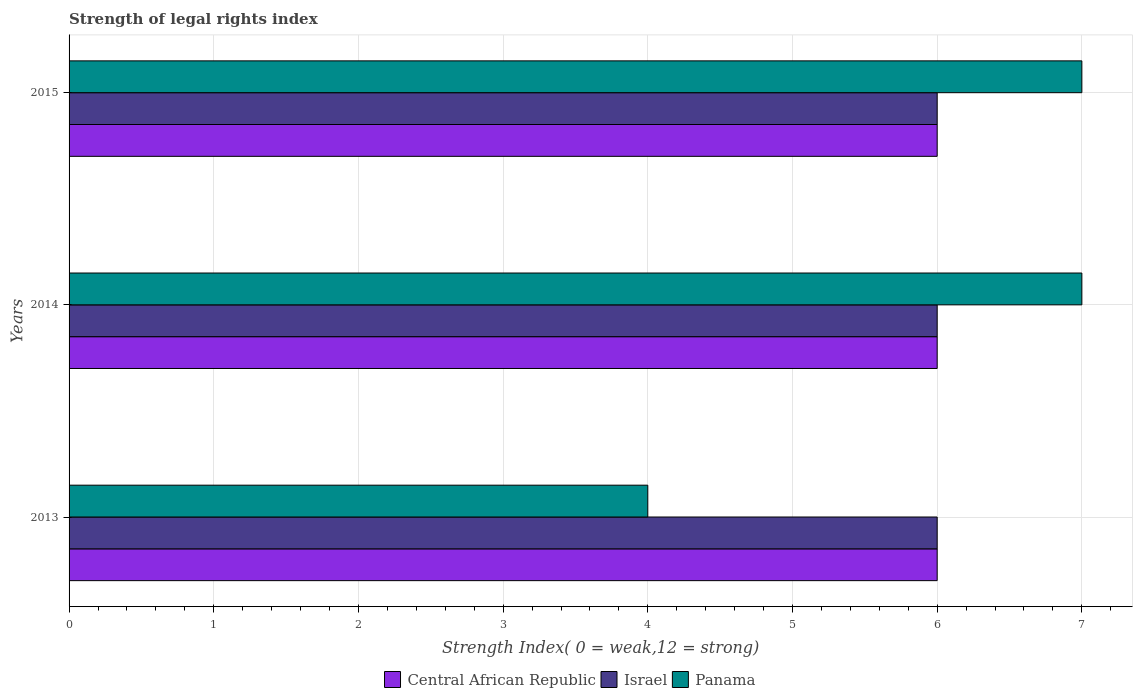Are the number of bars per tick equal to the number of legend labels?
Provide a succinct answer. Yes. Are the number of bars on each tick of the Y-axis equal?
Make the answer very short. Yes. How many bars are there on the 2nd tick from the bottom?
Your answer should be compact. 3. What is the strength index in Panama in 2013?
Ensure brevity in your answer.  4. Across all years, what is the maximum strength index in Panama?
Make the answer very short. 7. Across all years, what is the minimum strength index in Panama?
Give a very brief answer. 4. In which year was the strength index in Panama minimum?
Your answer should be compact. 2013. What is the total strength index in Israel in the graph?
Ensure brevity in your answer.  18. What is the difference between the strength index in Panama in 2014 and that in 2015?
Provide a short and direct response. 0. What is the difference between the strength index in Central African Republic in 2013 and the strength index in Panama in 2015?
Your answer should be compact. -1. What is the average strength index in Israel per year?
Your response must be concise. 6. What is the difference between the highest and the second highest strength index in Israel?
Offer a terse response. 0. What is the difference between the highest and the lowest strength index in Panama?
Offer a very short reply. 3. In how many years, is the strength index in Israel greater than the average strength index in Israel taken over all years?
Offer a very short reply. 0. What does the 1st bar from the top in 2015 represents?
Give a very brief answer. Panama. Is it the case that in every year, the sum of the strength index in Israel and strength index in Central African Republic is greater than the strength index in Panama?
Keep it short and to the point. Yes. Are all the bars in the graph horizontal?
Provide a succinct answer. Yes. What is the difference between two consecutive major ticks on the X-axis?
Offer a very short reply. 1. Does the graph contain grids?
Provide a succinct answer. Yes. Where does the legend appear in the graph?
Keep it short and to the point. Bottom center. How many legend labels are there?
Your answer should be compact. 3. How are the legend labels stacked?
Make the answer very short. Horizontal. What is the title of the graph?
Make the answer very short. Strength of legal rights index. Does "Uzbekistan" appear as one of the legend labels in the graph?
Provide a succinct answer. No. What is the label or title of the X-axis?
Provide a short and direct response. Strength Index( 0 = weak,12 = strong). What is the label or title of the Y-axis?
Give a very brief answer. Years. What is the Strength Index( 0 = weak,12 = strong) in Israel in 2013?
Ensure brevity in your answer.  6. What is the Strength Index( 0 = weak,12 = strong) of Panama in 2013?
Your response must be concise. 4. What is the Strength Index( 0 = weak,12 = strong) in Central African Republic in 2015?
Your answer should be compact. 6. What is the Strength Index( 0 = weak,12 = strong) in Panama in 2015?
Your answer should be compact. 7. Across all years, what is the maximum Strength Index( 0 = weak,12 = strong) of Central African Republic?
Make the answer very short. 6. Across all years, what is the maximum Strength Index( 0 = weak,12 = strong) in Israel?
Keep it short and to the point. 6. Across all years, what is the maximum Strength Index( 0 = weak,12 = strong) of Panama?
Keep it short and to the point. 7. Across all years, what is the minimum Strength Index( 0 = weak,12 = strong) in Panama?
Your answer should be compact. 4. What is the total Strength Index( 0 = weak,12 = strong) in Panama in the graph?
Ensure brevity in your answer.  18. What is the difference between the Strength Index( 0 = weak,12 = strong) of Central African Republic in 2013 and that in 2014?
Make the answer very short. 0. What is the difference between the Strength Index( 0 = weak,12 = strong) in Israel in 2013 and that in 2014?
Your answer should be compact. 0. What is the difference between the Strength Index( 0 = weak,12 = strong) of Panama in 2013 and that in 2014?
Your response must be concise. -3. What is the difference between the Strength Index( 0 = weak,12 = strong) of Central African Republic in 2013 and that in 2015?
Your answer should be compact. 0. What is the difference between the Strength Index( 0 = weak,12 = strong) in Panama in 2013 and that in 2015?
Your answer should be compact. -3. What is the difference between the Strength Index( 0 = weak,12 = strong) in Israel in 2014 and that in 2015?
Your answer should be very brief. 0. What is the difference between the Strength Index( 0 = weak,12 = strong) of Panama in 2014 and that in 2015?
Offer a terse response. 0. What is the difference between the Strength Index( 0 = weak,12 = strong) in Central African Republic in 2013 and the Strength Index( 0 = weak,12 = strong) in Israel in 2014?
Provide a succinct answer. 0. What is the difference between the Strength Index( 0 = weak,12 = strong) of Central African Republic in 2013 and the Strength Index( 0 = weak,12 = strong) of Panama in 2014?
Make the answer very short. -1. What is the difference between the Strength Index( 0 = weak,12 = strong) in Israel in 2013 and the Strength Index( 0 = weak,12 = strong) in Panama in 2015?
Offer a terse response. -1. What is the difference between the Strength Index( 0 = weak,12 = strong) of Central African Republic in 2014 and the Strength Index( 0 = weak,12 = strong) of Israel in 2015?
Your response must be concise. 0. What is the difference between the Strength Index( 0 = weak,12 = strong) of Central African Republic in 2014 and the Strength Index( 0 = weak,12 = strong) of Panama in 2015?
Ensure brevity in your answer.  -1. What is the average Strength Index( 0 = weak,12 = strong) in Central African Republic per year?
Provide a short and direct response. 6. In the year 2013, what is the difference between the Strength Index( 0 = weak,12 = strong) of Central African Republic and Strength Index( 0 = weak,12 = strong) of Israel?
Your answer should be very brief. 0. In the year 2013, what is the difference between the Strength Index( 0 = weak,12 = strong) of Central African Republic and Strength Index( 0 = weak,12 = strong) of Panama?
Make the answer very short. 2. In the year 2013, what is the difference between the Strength Index( 0 = weak,12 = strong) in Israel and Strength Index( 0 = weak,12 = strong) in Panama?
Your response must be concise. 2. In the year 2014, what is the difference between the Strength Index( 0 = weak,12 = strong) of Central African Republic and Strength Index( 0 = weak,12 = strong) of Israel?
Keep it short and to the point. 0. In the year 2014, what is the difference between the Strength Index( 0 = weak,12 = strong) of Central African Republic and Strength Index( 0 = weak,12 = strong) of Panama?
Make the answer very short. -1. In the year 2014, what is the difference between the Strength Index( 0 = weak,12 = strong) in Israel and Strength Index( 0 = weak,12 = strong) in Panama?
Provide a succinct answer. -1. In the year 2015, what is the difference between the Strength Index( 0 = weak,12 = strong) in Central African Republic and Strength Index( 0 = weak,12 = strong) in Panama?
Provide a short and direct response. -1. In the year 2015, what is the difference between the Strength Index( 0 = weak,12 = strong) of Israel and Strength Index( 0 = weak,12 = strong) of Panama?
Your answer should be compact. -1. What is the ratio of the Strength Index( 0 = weak,12 = strong) in Israel in 2013 to that in 2015?
Your response must be concise. 1. What is the ratio of the Strength Index( 0 = weak,12 = strong) in Panama in 2014 to that in 2015?
Give a very brief answer. 1. What is the difference between the highest and the second highest Strength Index( 0 = weak,12 = strong) in Central African Republic?
Provide a succinct answer. 0. What is the difference between the highest and the second highest Strength Index( 0 = weak,12 = strong) in Israel?
Ensure brevity in your answer.  0. What is the difference between the highest and the lowest Strength Index( 0 = weak,12 = strong) in Central African Republic?
Offer a very short reply. 0. What is the difference between the highest and the lowest Strength Index( 0 = weak,12 = strong) in Israel?
Provide a succinct answer. 0. 